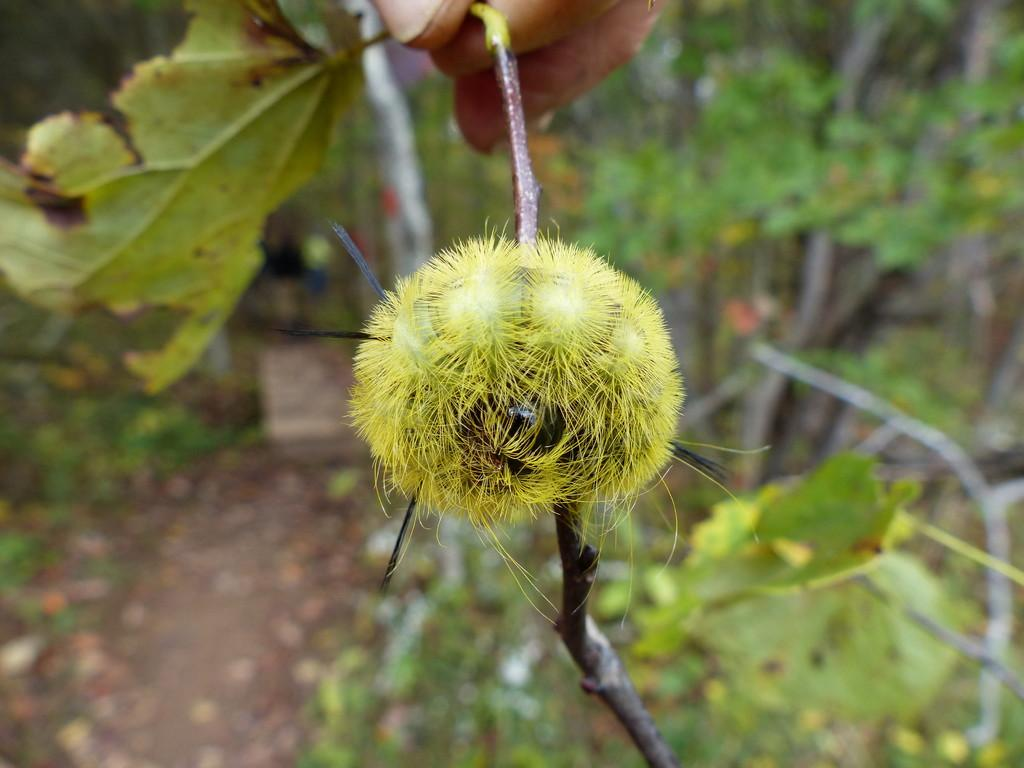What type of plant can be seen in the image? There is a plant with a flower in the image. What other vegetation is present in the image? There are trees in the image. What can be seen beneath the plants and trees? The ground is visible in the image. Are there any fallen plant parts on the ground? Yes, there are leaves on the ground in the image. How much income does the plant with a flower generate in the image? There is no information about income in the image; it is a photograph of a plant with a flower, trees, the ground, and fallen leaves. 